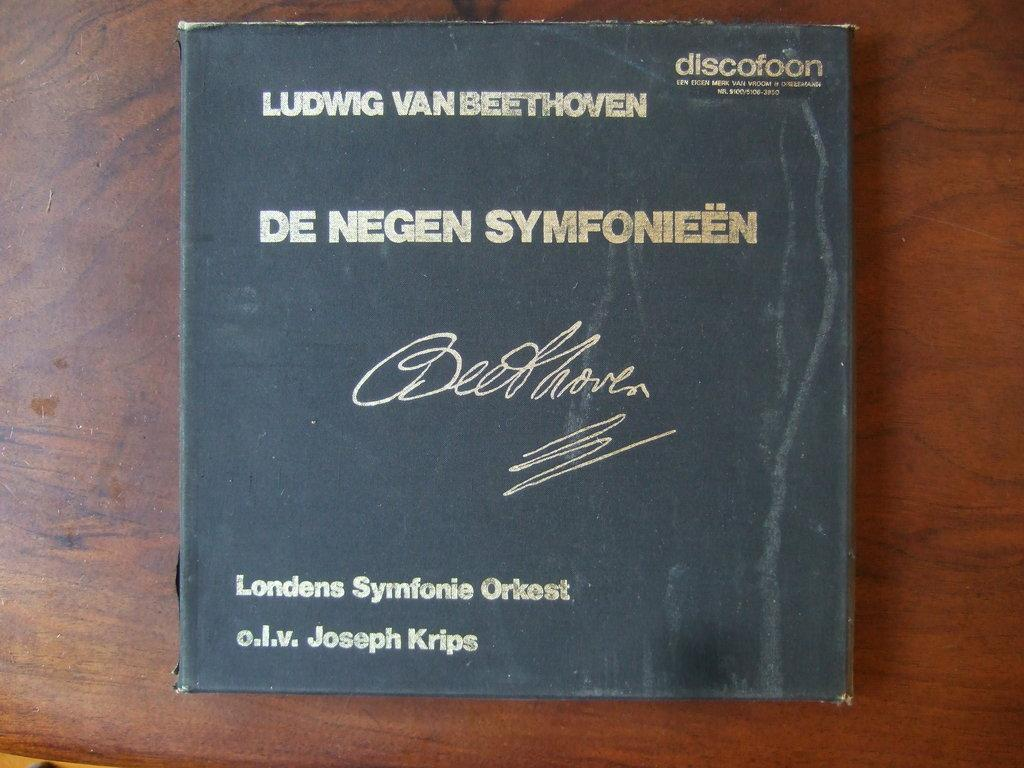<image>
Write a terse but informative summary of the picture. A black binder with gold lettering with the work of Ludwig Van Beethoven by the Londens Symfonie Orkest 